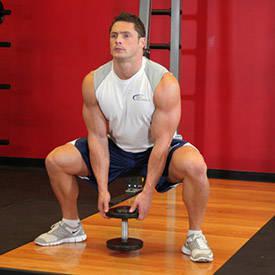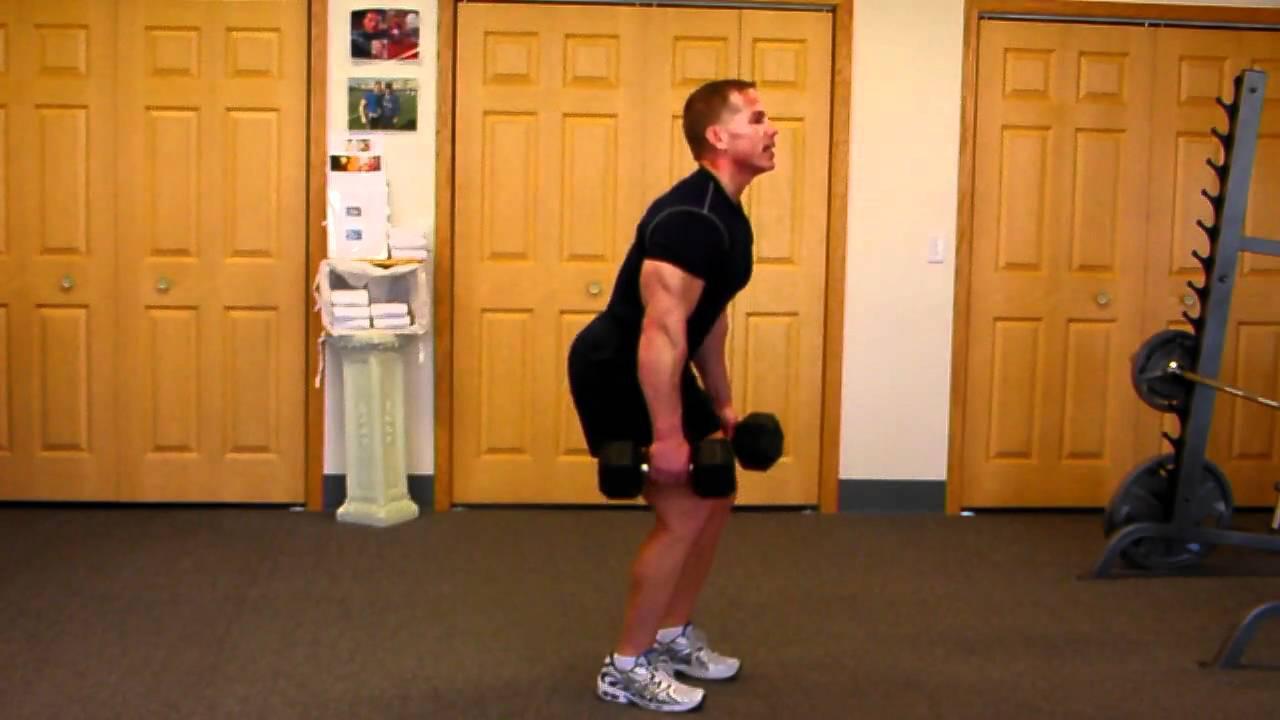The first image is the image on the left, the second image is the image on the right. For the images displayed, is the sentence "There is a man wearing a black shirt and black shorts with a dumbbell in each hand." factually correct? Answer yes or no. Yes. The first image is the image on the left, the second image is the image on the right. Analyze the images presented: Is the assertion "One of the guys does some leg-work near a red wall." valid? Answer yes or no. Yes. 